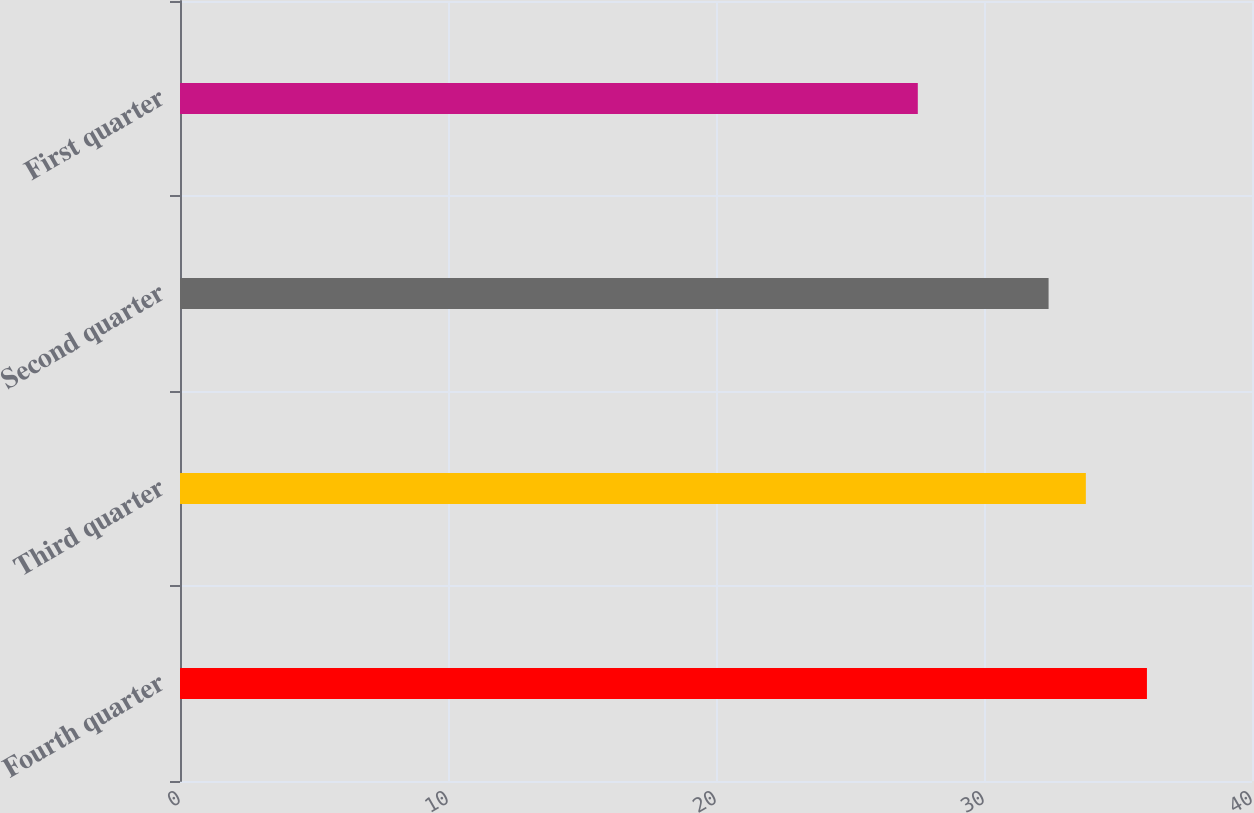<chart> <loc_0><loc_0><loc_500><loc_500><bar_chart><fcel>Fourth quarter<fcel>Third quarter<fcel>Second quarter<fcel>First quarter<nl><fcel>36.08<fcel>33.8<fcel>32.41<fcel>27.53<nl></chart> 